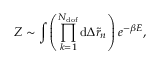Convert formula to latex. <formula><loc_0><loc_0><loc_500><loc_500>Z \sim \int { \left ( \prod _ { k = 1 } ^ { N _ { d o f } } { d \Delta \tilde { r } _ { n } } \right ) e ^ { - \beta E } } ,</formula> 